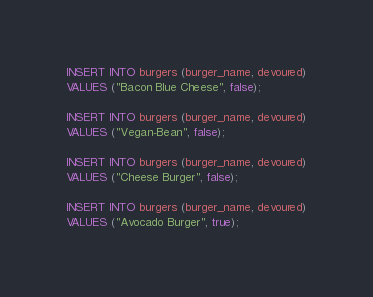Convert code to text. <code><loc_0><loc_0><loc_500><loc_500><_SQL_>INSERT INTO burgers (burger_name, devoured)
VALUES ("Bacon Blue Cheese", false);

INSERT INTO burgers (burger_name, devoured)
VALUES ("Vegan-Bean", false);

INSERT INTO burgers (burger_name, devoured)
VALUES ("Cheese Burger", false);

INSERT INTO burgers (burger_name, devoured)
VALUES ("Avocado Burger", true);</code> 